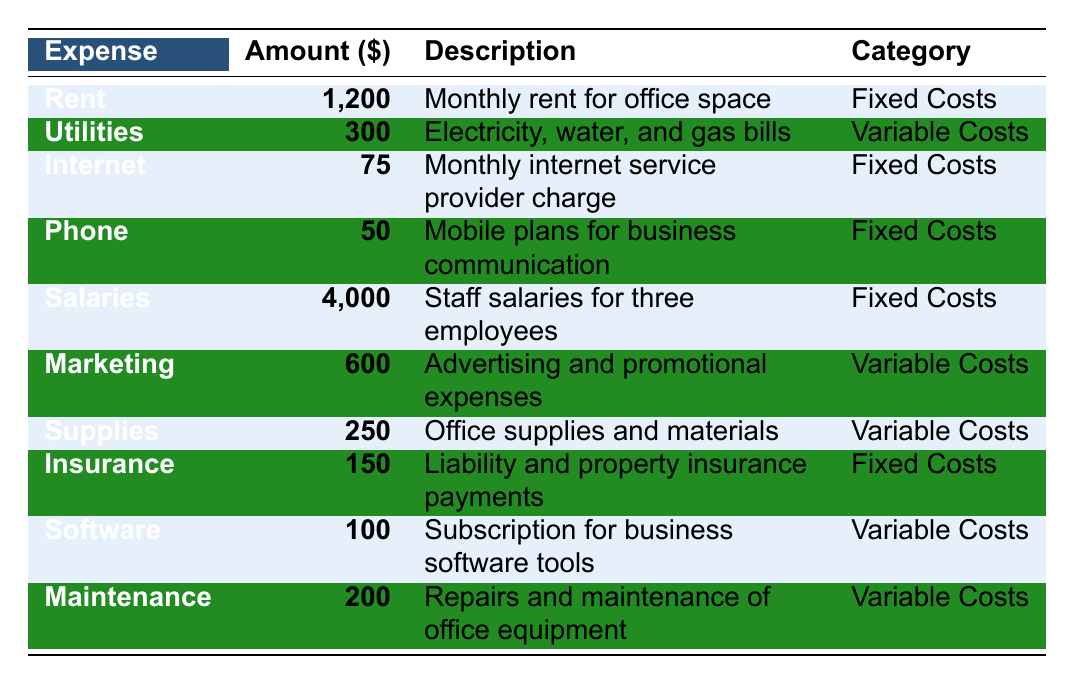What is the total amount spent on fixed costs? To find the total fixed costs, add the amounts for Rent (1200), Internet (75), Phone (50), Salaries (4000), and Insurance (150). The sum is 1200 + 75 + 50 + 4000 + 150 = 5475.
Answer: 5475 What is the expense for utilities? The table lists Utilities with an amount of 300.
Answer: 300 How much is spent on marketing and supplies combined? To calculate the combined expense for Marketing (600) and Supplies (250), sum them: 600 + 250 = 850.
Answer: 850 Is the monthly internet service more expensive than the phone plan? The monthly internet service is 75, and the phone plan costs 50. Since 75 > 50, the statement is true.
Answer: Yes What is the average cost of variable expenses? The variable expenses are Utilities (300), Marketing (600), Supplies (250), Software (100), and Maintenance (200). Their total is 300 + 600 + 250 + 100 + 200 = 1450. Since there are 5 variable expenses, the average is 1450 / 5 = 290.
Answer: 290 What is the total monthly expense across all categories? First, we need to sum all the expenses listed: Rent (1200), Utilities (300), Internet (75), Phone (50), Salaries (4000), Marketing (600), Supplies (250), Insurance (150), Software (100), Maintenance (200), giving us 1200 + 300 + 75 + 50 + 4000 + 600 + 250 + 150 + 100 + 200 = 6125.
Answer: 6125 What percentage of the total expenses is allocated to salaries? Total expenses are 6125, and salaries are 4000. To find the percentage, divide 4000 by 6125 and then multiply by 100: (4000 / 6125) * 100 ≈ 65.34%.
Answer: Approximately 65.34% How much more is spent on fixed costs compared to variable costs? Fixed costs total is 5475 (from the first question). The variable costs total is 300 + 600 + 250 + 100 + 200 = 1450. The difference is 5475 - 1450 = 4025.
Answer: 4025 Are monthly internet costs less than maintenance costs? The table lists internet costs at 75 and maintenance costs at 200. Since 75 is less than 200, the statement is true.
Answer: Yes 